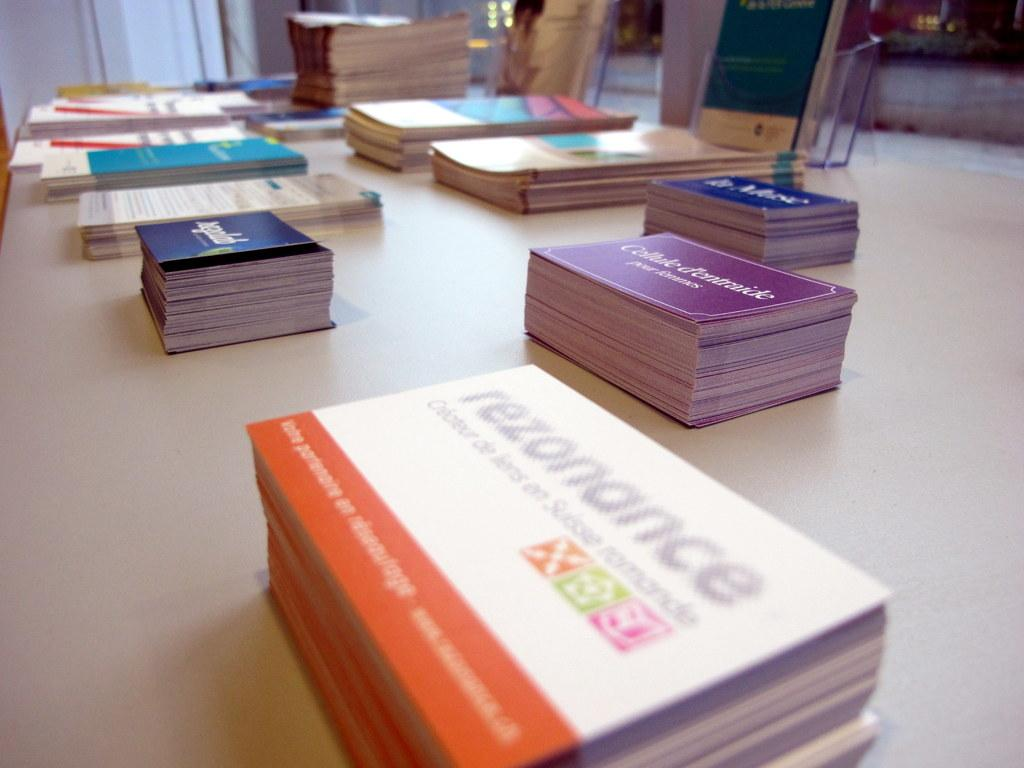What type of objects can be seen in the image? There are books in the image. Can you describe the other objects on the table in the image? Unfortunately, the provided facts do not specify the other objects on the table. However, we can infer that there are other objects present on the table since it is mentioned that there are "other objects" in addition to the books. What is the weather like at the lake in the image? There is no lake present in the image, so it is not possible to determine the weather at a lake. 